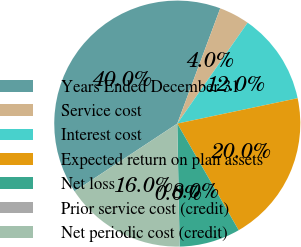Convert chart. <chart><loc_0><loc_0><loc_500><loc_500><pie_chart><fcel>Years Ended December 31<fcel>Service cost<fcel>Interest cost<fcel>Expected return on plan assets<fcel>Net loss<fcel>Prior service cost (credit)<fcel>Net periodic cost (credit)<nl><fcel>39.96%<fcel>4.01%<fcel>12.0%<fcel>19.99%<fcel>8.01%<fcel>0.02%<fcel>16.0%<nl></chart> 